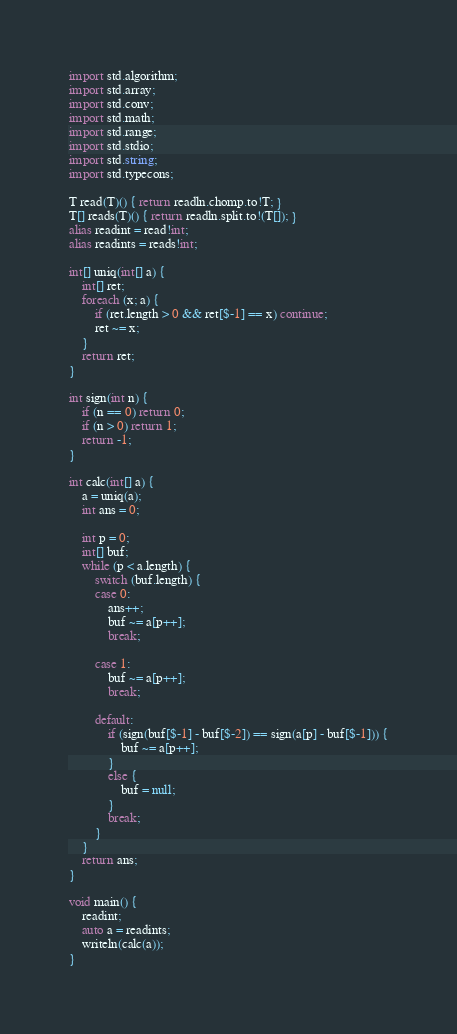<code> <loc_0><loc_0><loc_500><loc_500><_D_>import std.algorithm;
import std.array;
import std.conv;
import std.math;
import std.range;
import std.stdio;
import std.string;
import std.typecons;

T read(T)() { return readln.chomp.to!T; }
T[] reads(T)() { return readln.split.to!(T[]); }
alias readint = read!int;
alias readints = reads!int;

int[] uniq(int[] a) {
    int[] ret;
    foreach (x; a) {
        if (ret.length > 0 && ret[$-1] == x) continue;
        ret ~= x;
    }
    return ret;
}

int sign(int n) {
    if (n == 0) return 0;
    if (n > 0) return 1;
    return -1;
}

int calc(int[] a) {
    a = uniq(a);
    int ans = 0;

    int p = 0;
    int[] buf;
    while (p < a.length) {
        switch (buf.length) {
        case 0:
            ans++;
            buf ~= a[p++];
            break;

        case 1:
            buf ~= a[p++];
            break;

        default:
            if (sign(buf[$-1] - buf[$-2]) == sign(a[p] - buf[$-1])) {
                buf ~= a[p++];
            }
            else {
                buf = null;
            }
            break;
        }
    }
    return ans;
}

void main() {
    readint;
    auto a = readints;
    writeln(calc(a));
}
</code> 